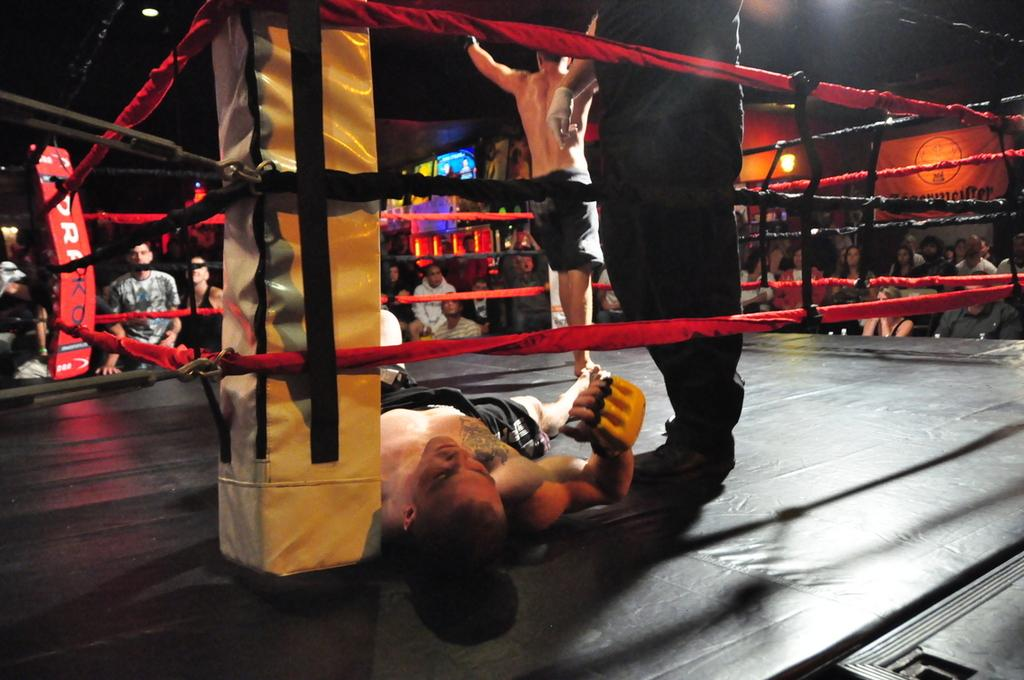Who or what can be seen in the image in the image? There are people in the image. What is the main feature of the image? There is a boxing ring in the image. What can be seen in the background of the image? There are lights and a board in the background of the image. What type of sign is hanging above the boxing ring in the image? There is no sign hanging above the boxing ring in the image. How many knots are tied on the ropes of the boxing ring in the image? The image does not show any knots on the ropes of the boxing ring. 